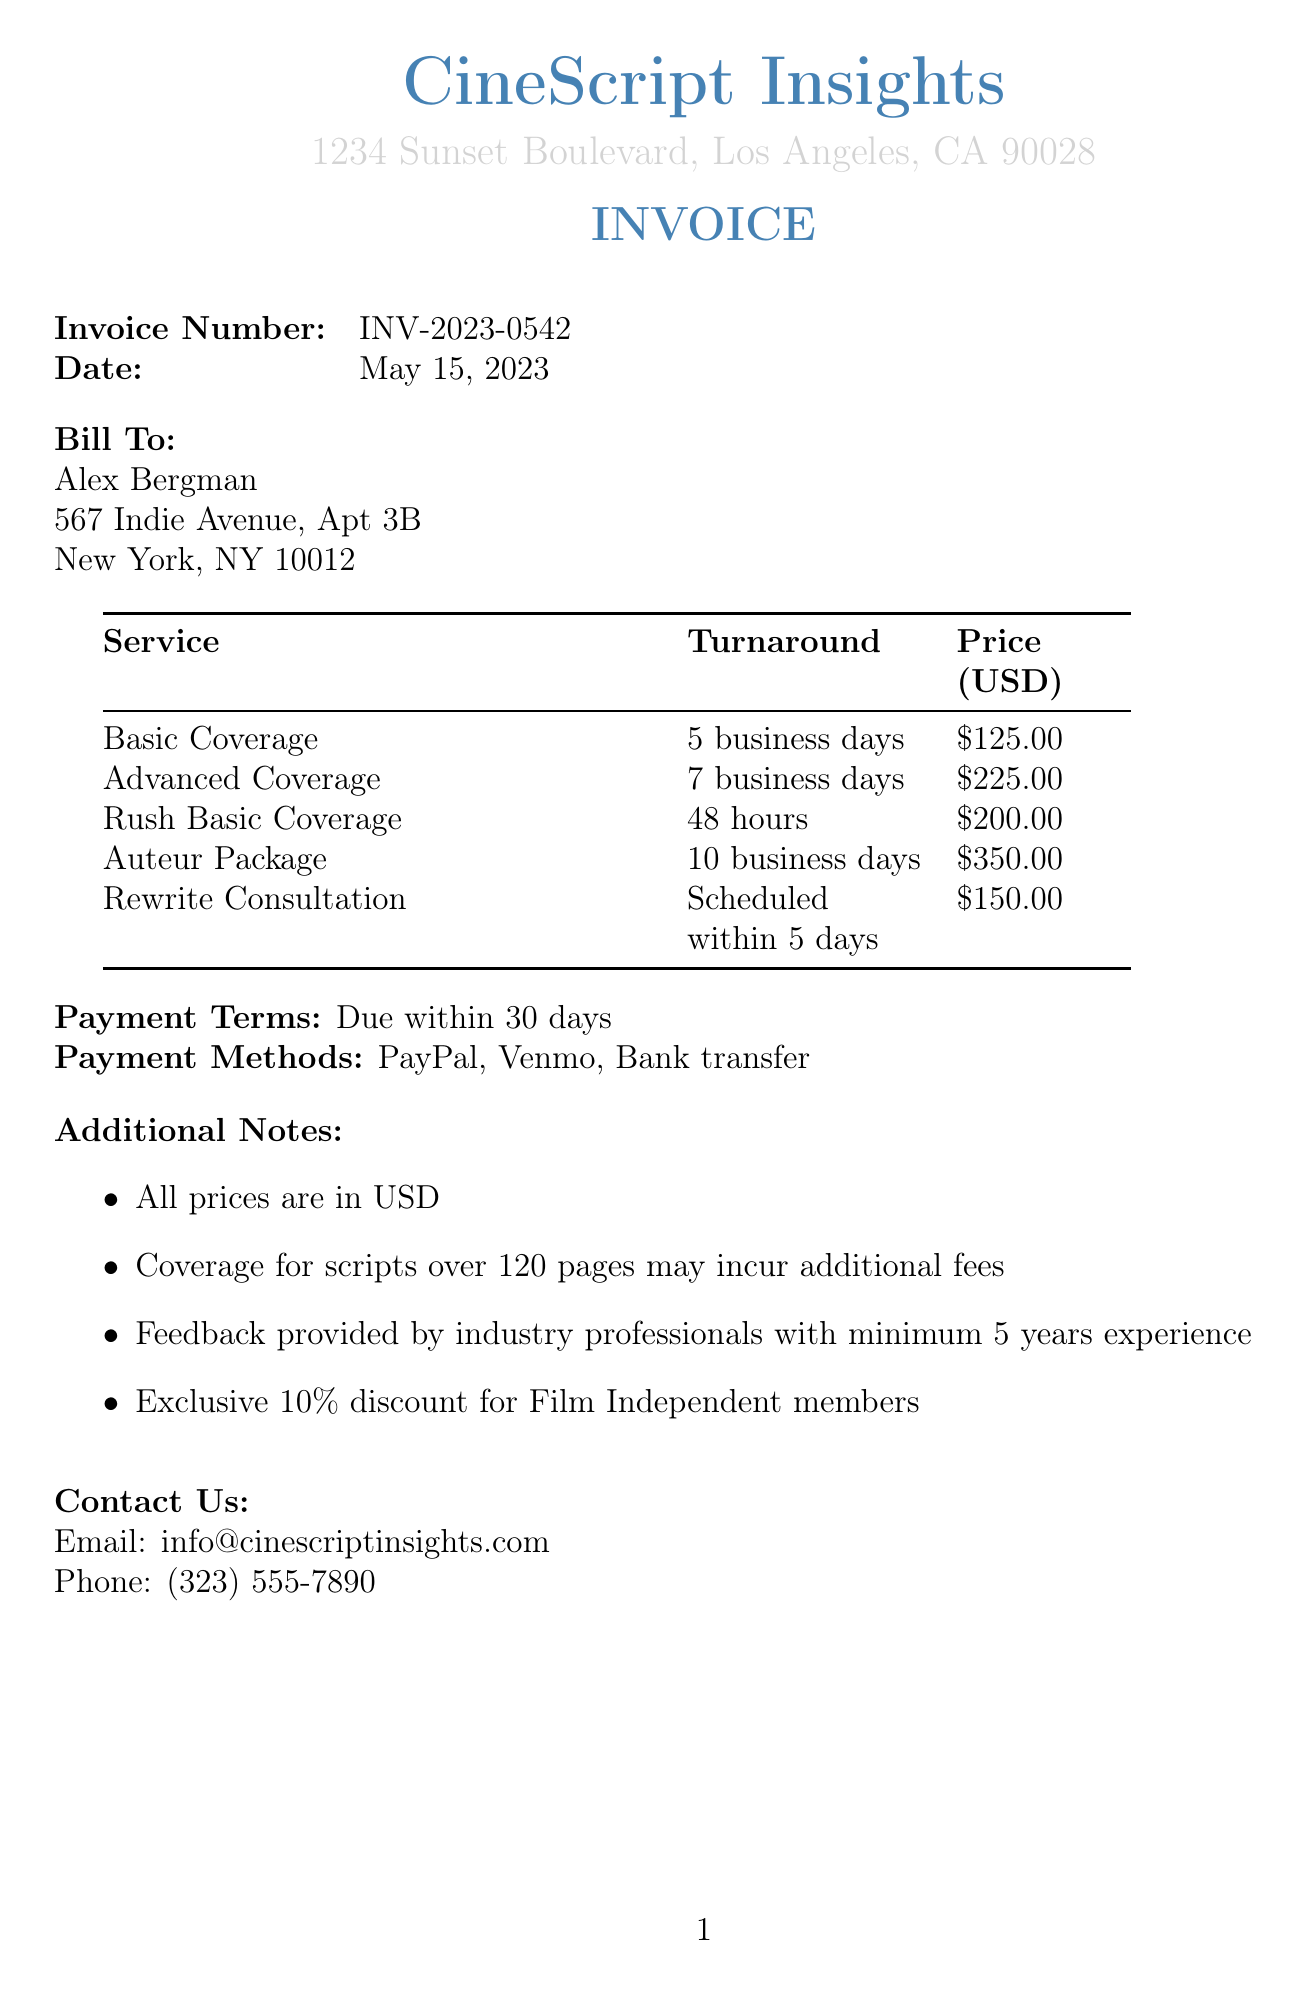What is the name of the company? The company name is presented at the top of the invoice.
Answer: CineScript Insights Who is the client? The client's name is mentioned directly below the billing information.
Answer: Alex Bergman How many services are listed in the invoice? The number of services is determined by counting the items in the services table.
Answer: 5 What is the price of the Advanced Coverage service? The price is stated in the services table under the Advanced Coverage section.
Answer: $225.00 What is the turnaround time for the Rush Basic Coverage? The turnaround time is listed alongside the service in the invoice.
Answer: 48 hours What discount is offered for Film Independent members? The document mentions a specific discount for members.
Answer: 10% What payment methods are available? The available payment methods are listed in the invoice.
Answer: PayPal, Venmo, Bank transfer When is the payment due? The payment terms clearly state the deadline for payment.
Answer: Due within 30 days What is included in the Rewrite Consultation? The description specifies what the service entails in terms of consultation.
Answer: One-hour video call to discuss potential rewrites 